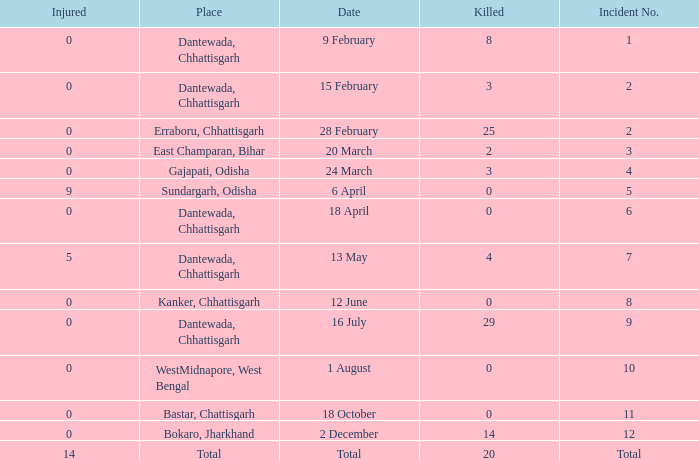How many people were injured in total in East Champaran, Bihar with more than 2 people killed? 0.0. 